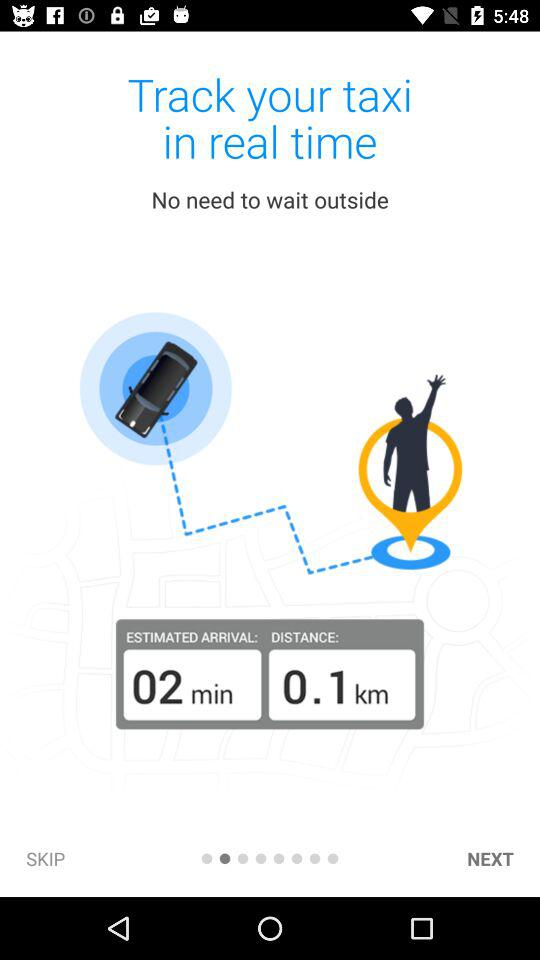How far is the taxi from the pickup location?
Answer the question using a single word or phrase. 0.1 km 